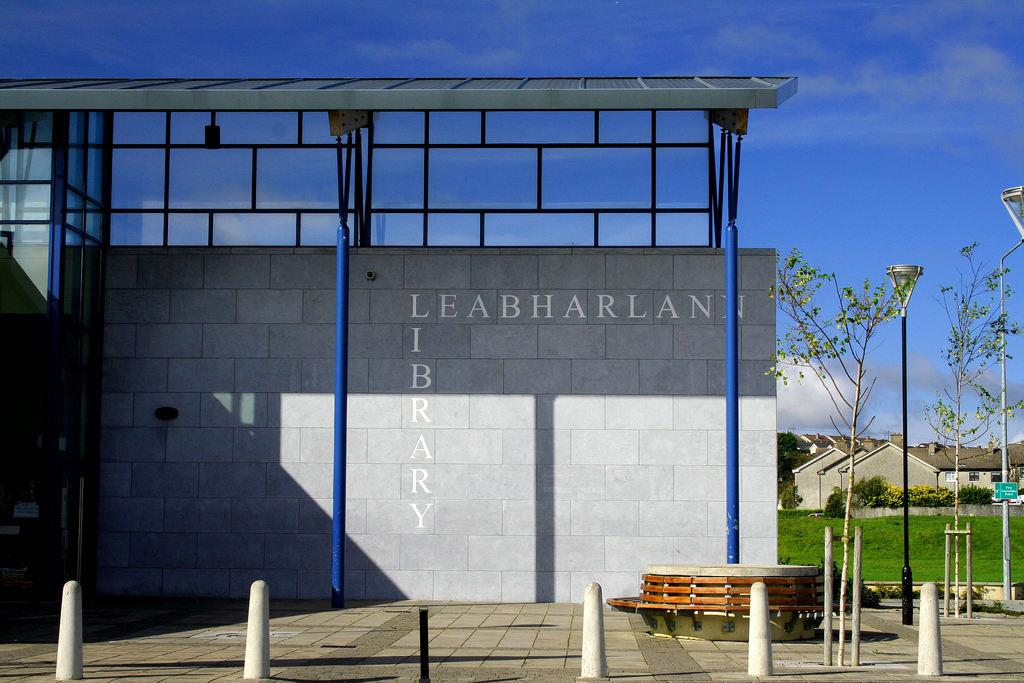What is written or depicted on the wall in the image? There is a wall with text in the image. What type of natural environment can be seen in the background of the image? There is grass visible in the background of the image. What type of structures can be seen in the background of the image? There are houses in the background of the image. What is visible in the sky in the background of the image? Clouds are present in the sky in the background of the image. How many mice are hiding behind the houses in the image? There are no mice visible in the image; it only shows a wall with text, grass, houses, and clouds in the sky. 